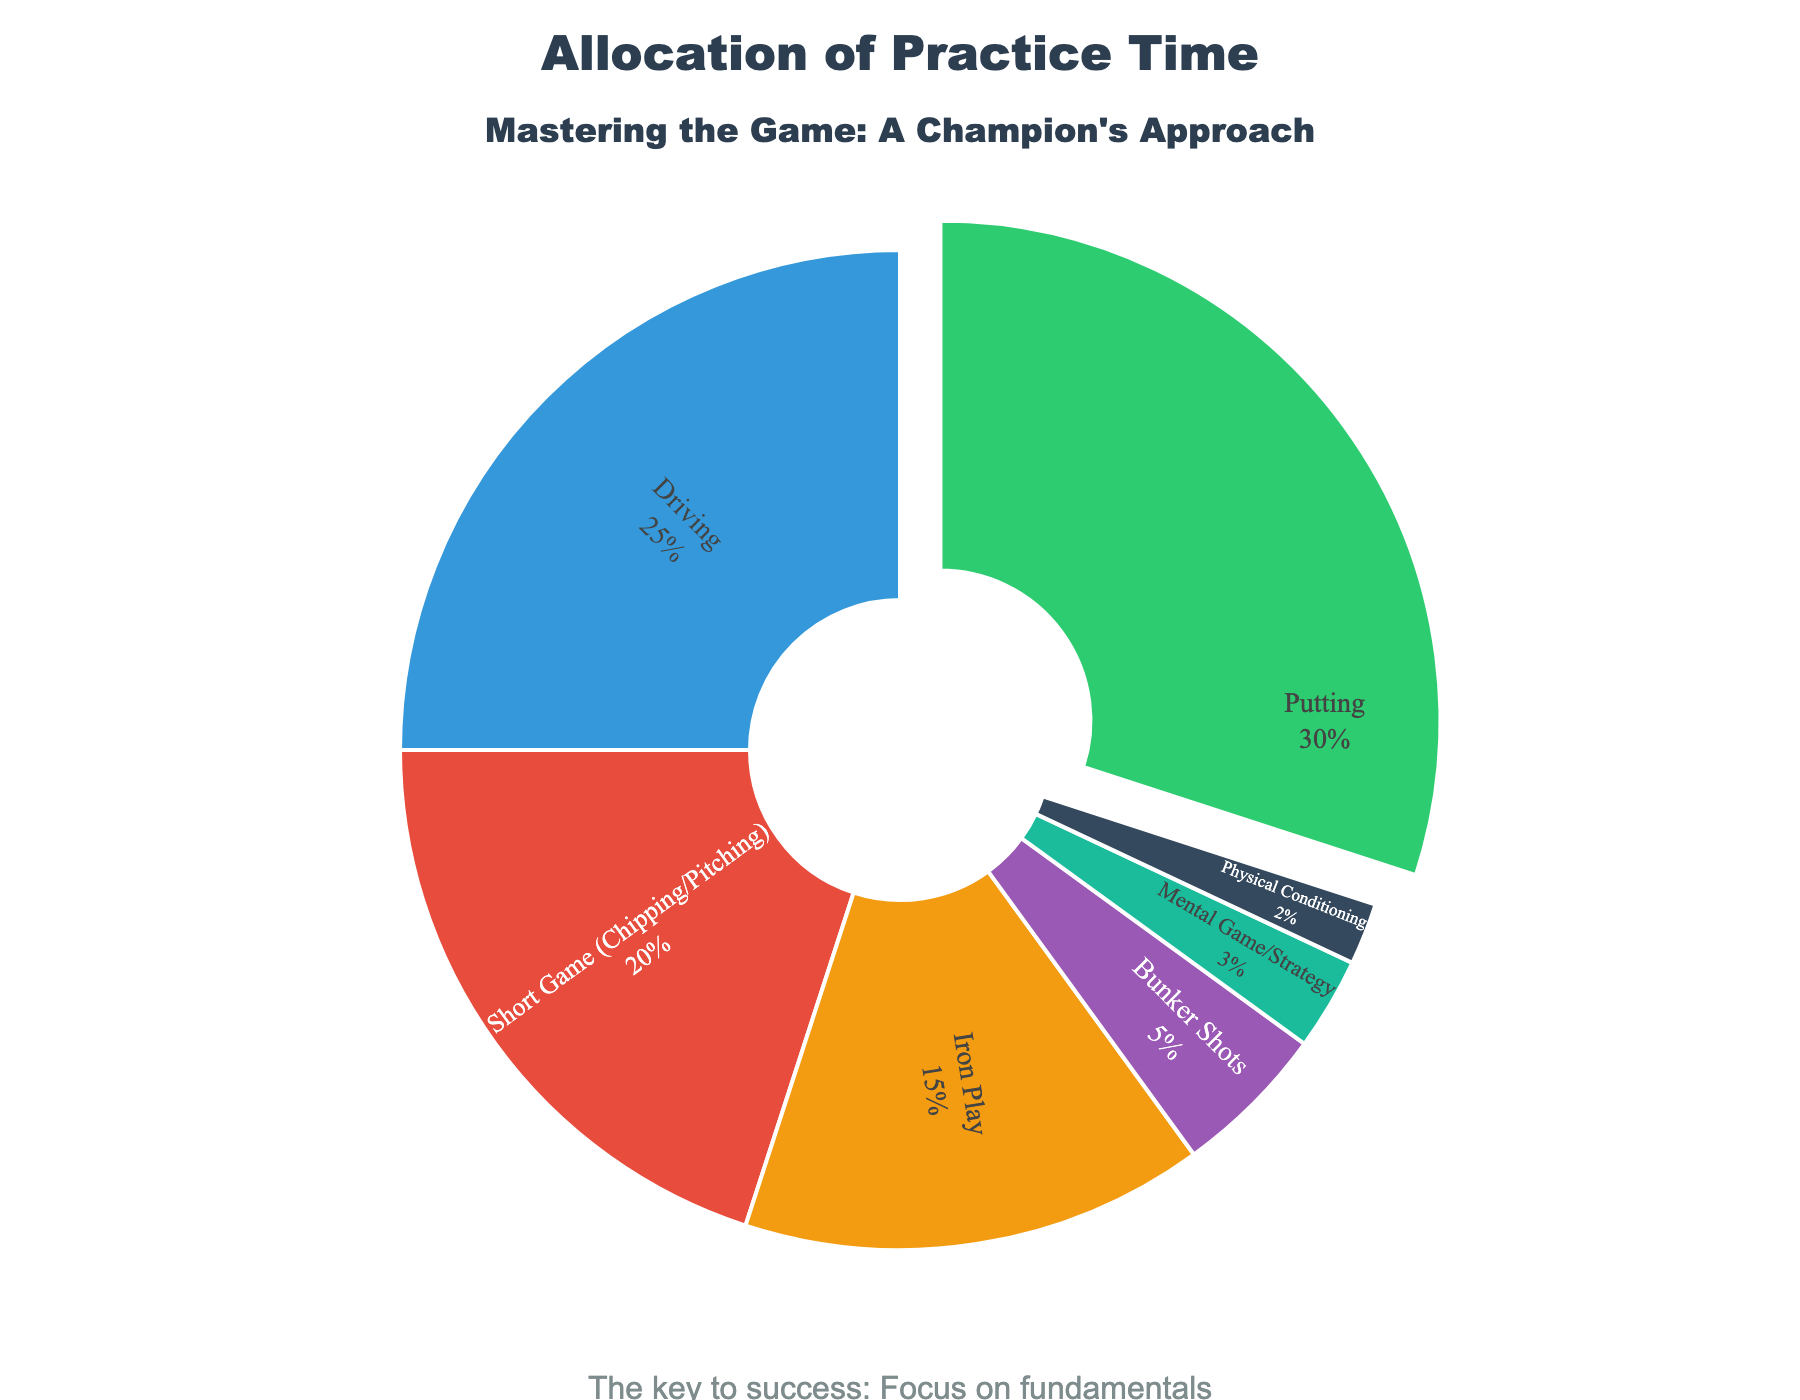what percentage of practice time is dedicated to putting? The segment labeled "Putting" shows 30% of the practice time. Simply refer to the pie chart to get this value.
Answer: 30% how much more time is spent on driving compared to bunker shots? The percentage of time spent on driving is 25%, and the percentage for bunker shots is 5%. The difference can be found by subtracting the latter from the former: 25% - 5% = 20%.
Answer: 20% which aspect has the lowest practice time allocation? The pie chart segment labeled "Physical Conditioning" shows the smallest percentage of practice time, at 2%.
Answer: Physical Conditioning is there more time spent on mental game/strategy or iron play? The segment for "Iron Play" shows 15%, whereas the segment for "Mental Game/Strategy" shows 3%. Since 15% is greater than 3%, more time is spent on iron play.
Answer: Iron Play what is the combined percentage for all aspects except putting and driving? Adding the percentages for short game (20%), iron play (15%), bunker shots (5%), mental game/strategy (3%), and physical conditioning (2%), we get: 20% + 15% + 5% + 3% + 2% = 45%.
Answer: 45% how many other practice aspects together make up the same percentage as putting? Putting accounts for 30% of the practice time. By adding up the smallest percentages first: Physical Conditioning (2%), Mental Game/Strategy (3%), Bunker Shots (5%), and Iron Play (15%). The total is 2% + 3% + 5% + 15% = 25%. Adding the next smallest, Short Game (20%) would exceed 30%, so four other aspects are required to get close to the percentage allocated to Putting.
Answer: 4 which aspect is represented by the green color in the pie chart? The pie chart uses green to represent the "Putting" segment, as noted by the color-coding in the chart.
Answer: Putting what is the average percentage of time allocated to bunker shots, mental game/strategy, and physical conditioning? Summing the given percentages: Bunker Shots (5%), Mental Game/Strategy (3%), and Physical Conditioning (2%) gives a total of 10%. The average is found by dividing this total by the number of aspects: 10% / 3 ≈ 3.33%.
Answer: 3.33% 